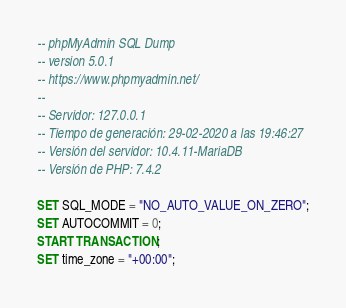Convert code to text. <code><loc_0><loc_0><loc_500><loc_500><_SQL_>-- phpMyAdmin SQL Dump
-- version 5.0.1
-- https://www.phpmyadmin.net/
--
-- Servidor: 127.0.0.1
-- Tiempo de generación: 29-02-2020 a las 19:46:27
-- Versión del servidor: 10.4.11-MariaDB
-- Versión de PHP: 7.4.2

SET SQL_MODE = "NO_AUTO_VALUE_ON_ZERO";
SET AUTOCOMMIT = 0;
START TRANSACTION;
SET time_zone = "+00:00";

</code> 